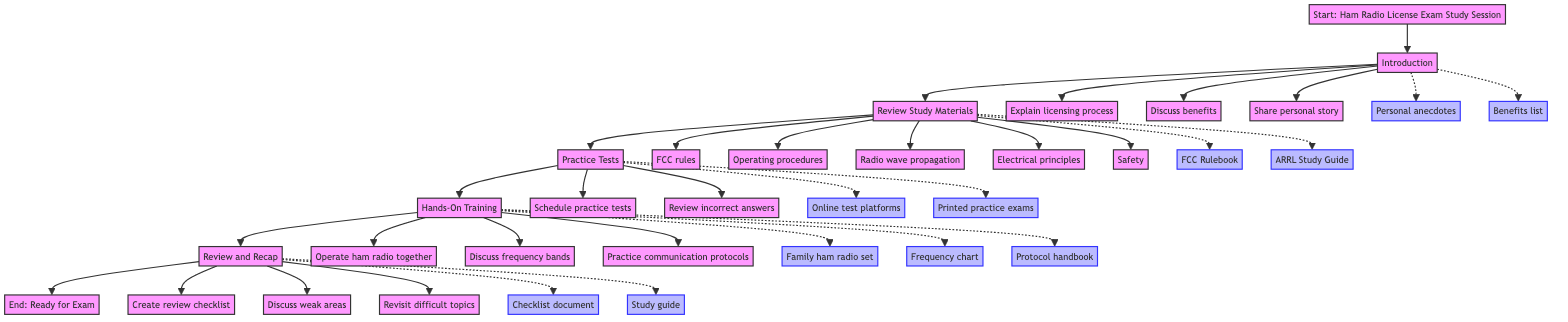What's the first step in the study session? The flowchart indicates that the first step, starting from the "Start: Ham Radio License Exam Study Session" node, is "Introduction".
Answer: Introduction How many main steps are there in the study session? By counting the main nodes in the flowchart, we can see that there are six main steps from "Introduction" to "Review and Recap" leading to the "End".
Answer: Six What activities are suggested during the "Hands-On Training"? From the flowchart, the activities under "Hands-On Training" include "Operate ham radio together", "Discuss different frequency bands", and "Practice proper communication protocols".
Answer: Operate ham radio together, Discuss different frequency bands, Practice proper communication protocols What resources are available for reviewing study materials? The flowchart specifies two key resources associated with reviewing study materials: the "FCC Rulebook" and the "ARRL Study Guide".
Answer: FCC Rulebook, ARRL Study Guide Which step follows "Practice Tests" in the flowchart? According to the flowchart, after the "Practice Tests" step, the next step in the sequence is "Hands-On Training".
Answer: Hands-On Training How are personal anecdotes used in the "Introduction"? The diagram notes that "Personal anecdotes" are categorized as a resource in the "Introduction" step, highlighting their role in sharing experiences.
Answer: Resource What should be created during the "Review and Recap" step? In the "Review and Recap" step, the flowchart indicates that participants should "Create a review checklist".
Answer: Create a review checklist What are the activities involved in "Review Study Materials"? The "Review Study Materials" step includes activities such as reviewing "FCC rules", "Operating procedures", "Radio wave propagation", "Electrical principles", and "Safety".
Answer: FCC rules, Operating procedures, Radio wave propagation, Electrical principles, Safety What types of tests are suggested in the "Practice Tests" step? The activities in the "Practice Tests" step include scheduling "practice test sessions" and reviewing "incorrect answers".
Answer: Practice test sessions, Review incorrect answers 